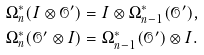Convert formula to latex. <formula><loc_0><loc_0><loc_500><loc_500>& \Omega ^ { * } _ { n } ( I \otimes \mathcal { O } ^ { \prime } ) = I \otimes \Omega ^ { * } _ { n - 1 } ( \mathcal { O } ^ { \prime } ) , \\ & \Omega ^ { * } _ { n } ( \mathcal { O } ^ { \prime } \otimes I ) = \Omega ^ { * } _ { n - 1 } ( \mathcal { O } ^ { \prime } ) \otimes I .</formula> 